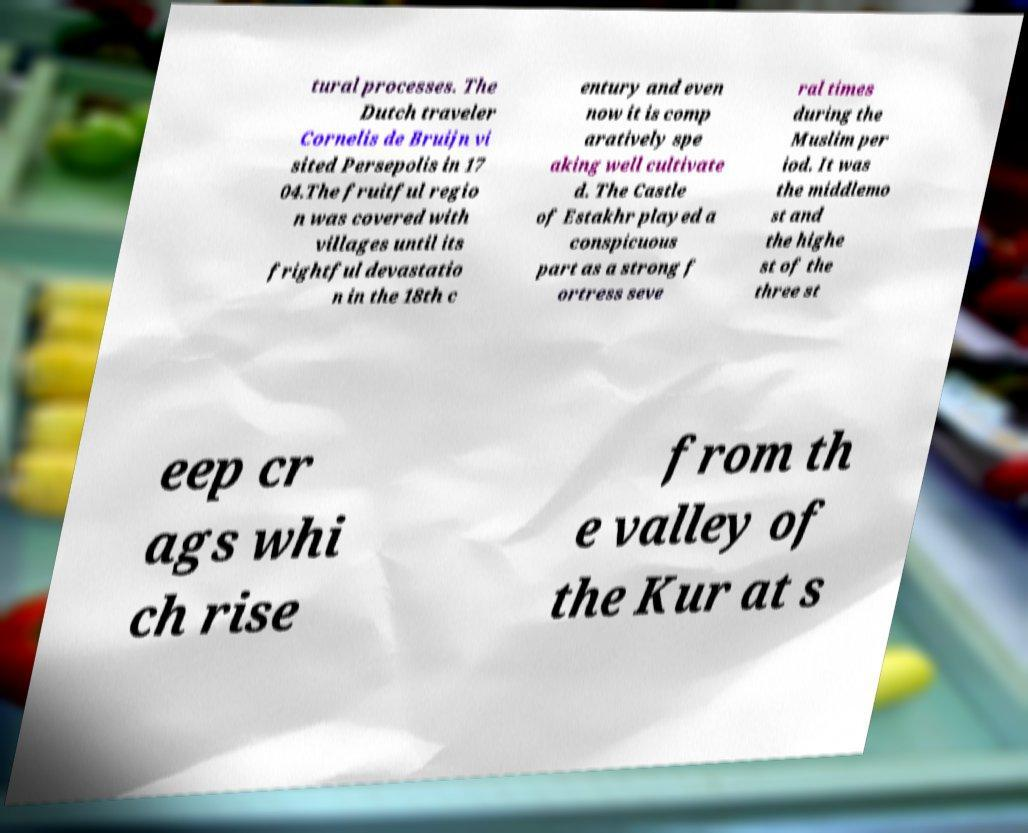Can you read and provide the text displayed in the image?This photo seems to have some interesting text. Can you extract and type it out for me? tural processes. The Dutch traveler Cornelis de Bruijn vi sited Persepolis in 17 04.The fruitful regio n was covered with villages until its frightful devastatio n in the 18th c entury and even now it is comp aratively spe aking well cultivate d. The Castle of Estakhr played a conspicuous part as a strong f ortress seve ral times during the Muslim per iod. It was the middlemo st and the highe st of the three st eep cr ags whi ch rise from th e valley of the Kur at s 